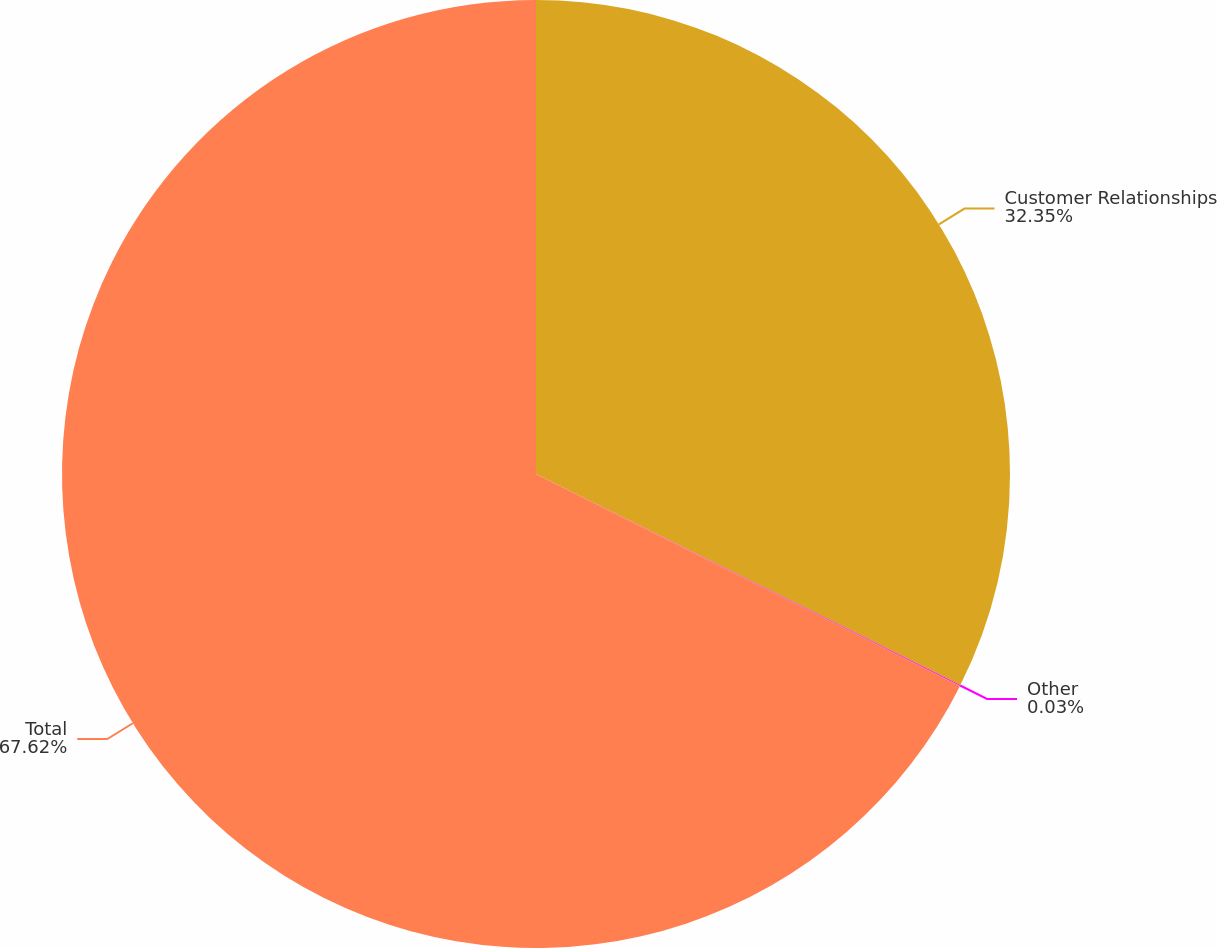Convert chart. <chart><loc_0><loc_0><loc_500><loc_500><pie_chart><fcel>Customer Relationships<fcel>Other<fcel>Total<nl><fcel>32.35%<fcel>0.03%<fcel>67.63%<nl></chart> 